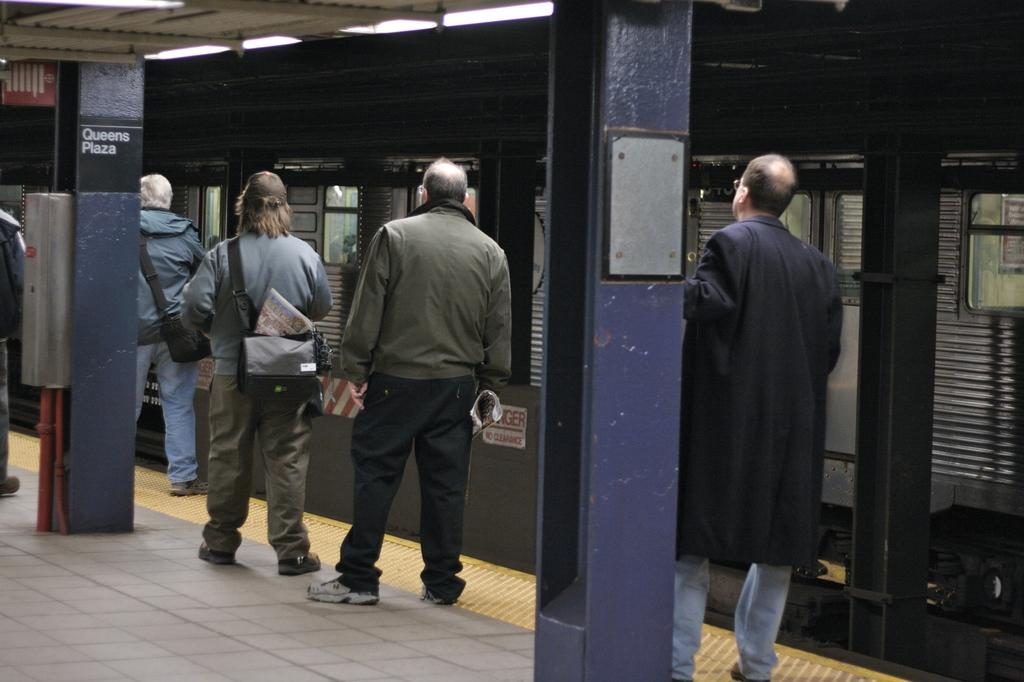What can be seen in the image involving people? There are people standing in the image. What are the people wearing? The people are wearing bags. Where are the people located in the image? The people are on a platform. What can be seen in the background of the image? There is a train visible in the image, and it is black in color. What other details can be observed in the image? There are blue color pillars in the image. What type of thread is being used to create the whip in the image? There is no whip present in the image, so it is not possible to determine what type of thread might be used. 